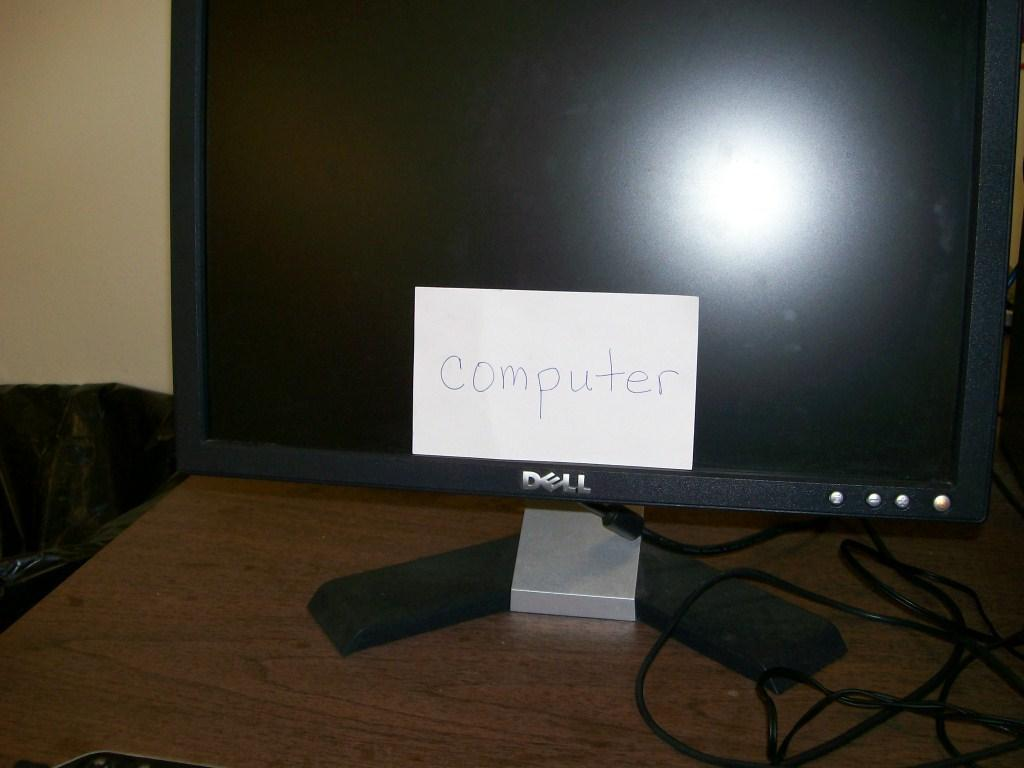<image>
Create a compact narrative representing the image presented. A Dell computer monitor has a post it on it that reads computer. 